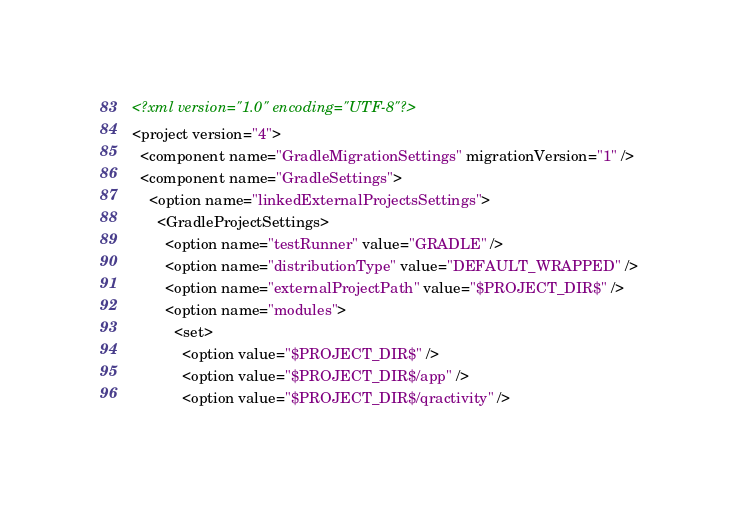Convert code to text. <code><loc_0><loc_0><loc_500><loc_500><_XML_><?xml version="1.0" encoding="UTF-8"?>
<project version="4">
  <component name="GradleMigrationSettings" migrationVersion="1" />
  <component name="GradleSettings">
    <option name="linkedExternalProjectsSettings">
      <GradleProjectSettings>
        <option name="testRunner" value="GRADLE" />
        <option name="distributionType" value="DEFAULT_WRAPPED" />
        <option name="externalProjectPath" value="$PROJECT_DIR$" />
        <option name="modules">
          <set>
            <option value="$PROJECT_DIR$" />
            <option value="$PROJECT_DIR$/app" />
            <option value="$PROJECT_DIR$/qractivity" /></code> 